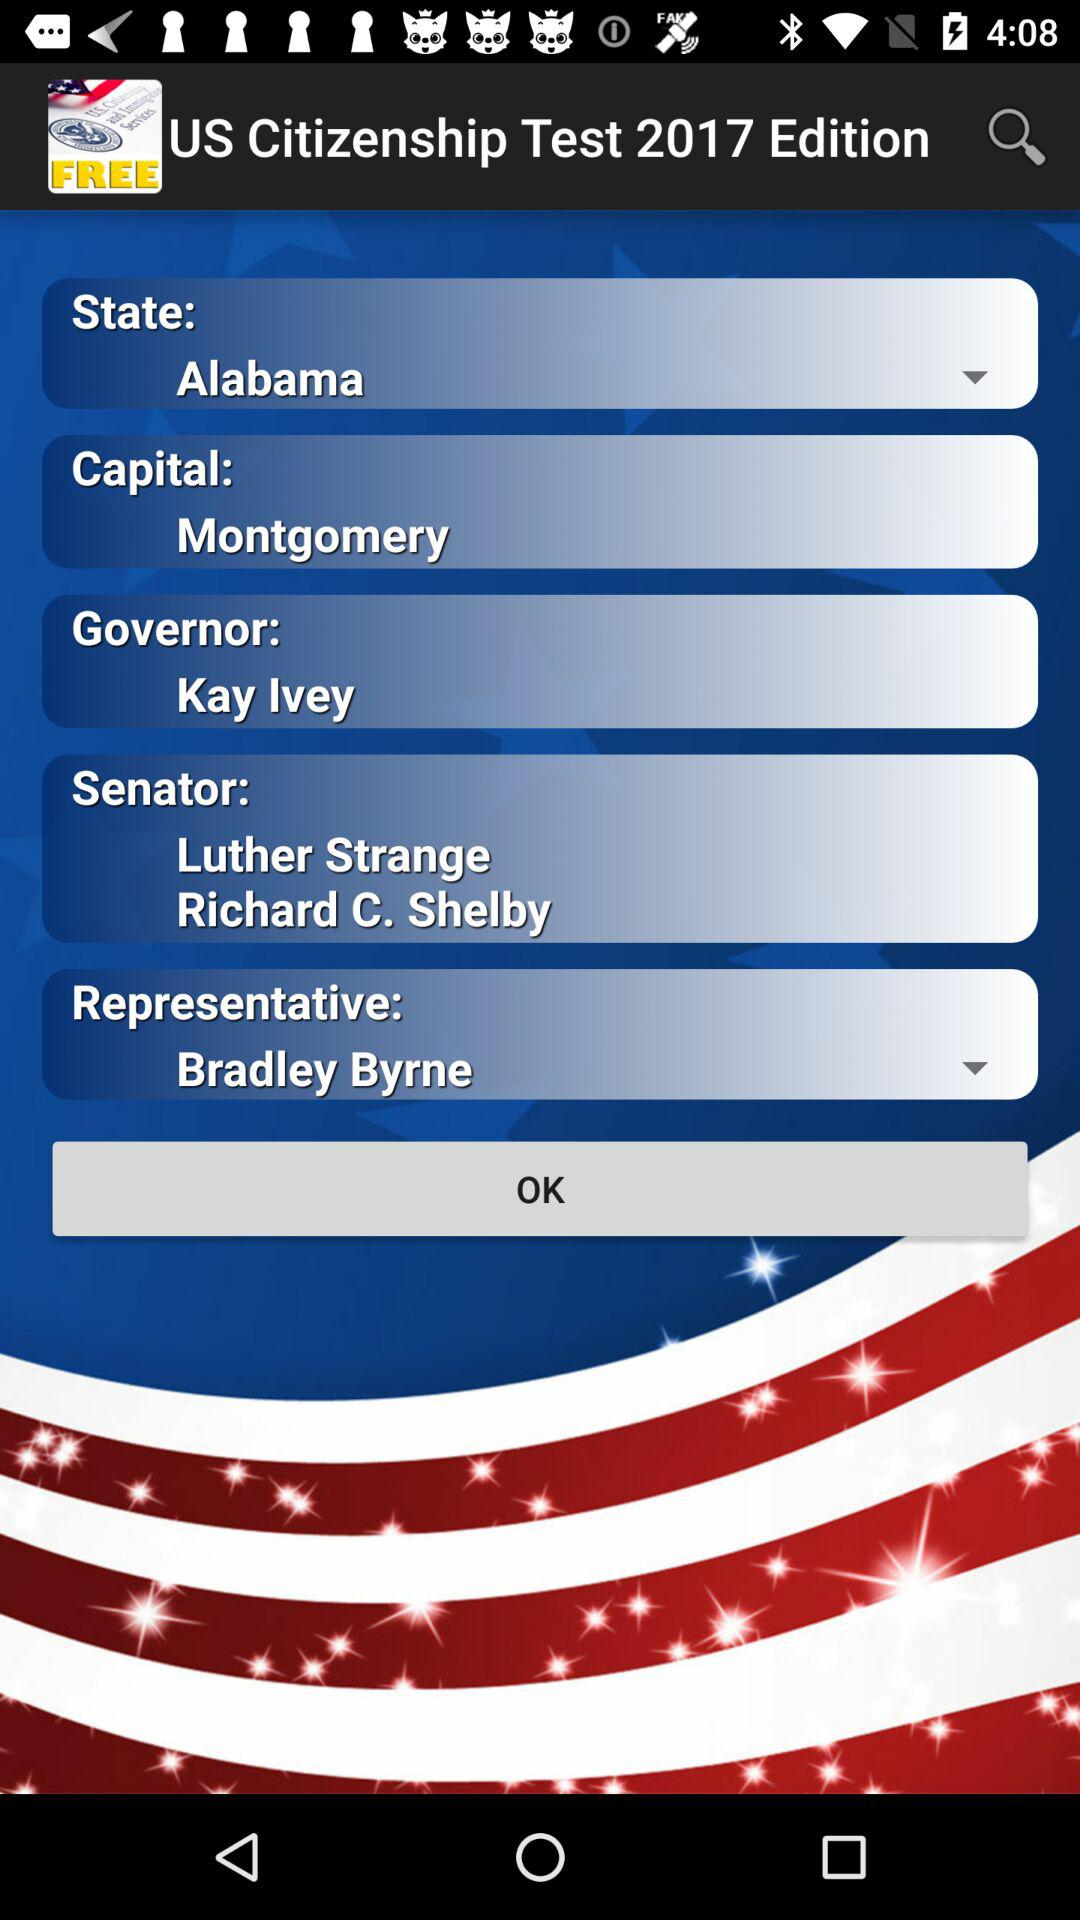What is the application name? The application name is "US Citizenship Test 2017 Edition". 